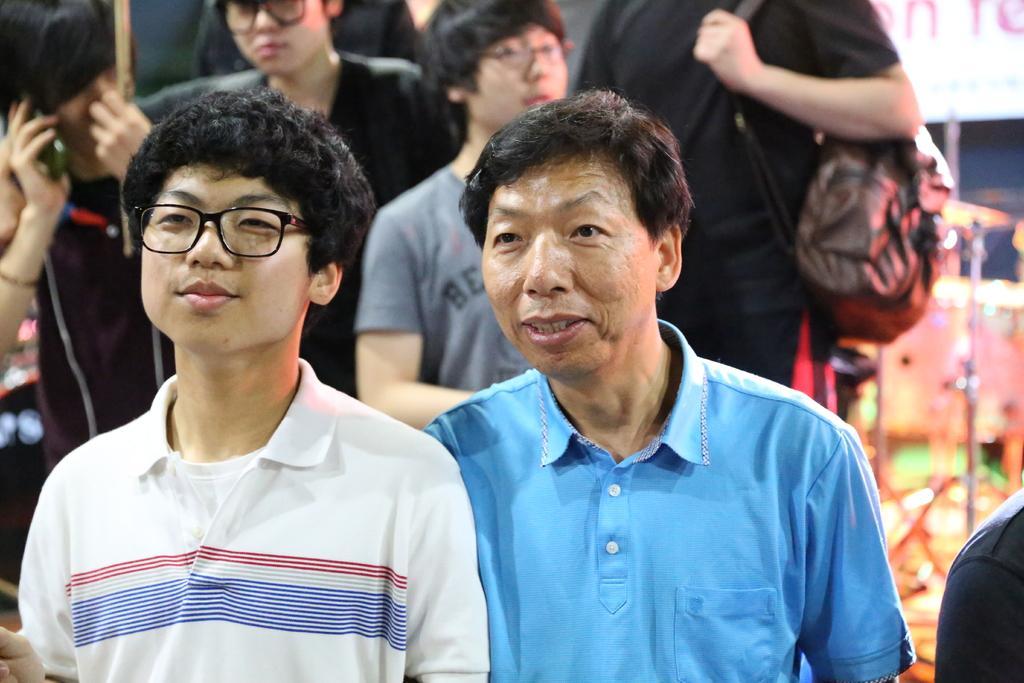Can you describe this image briefly? In this image we can see a group of people standing. One person is wearing a bag. On the left side of the image we can see a person holding a mobile and a stick in his hands. In the right side of the image we can see some stands, lights and a board with some text. 